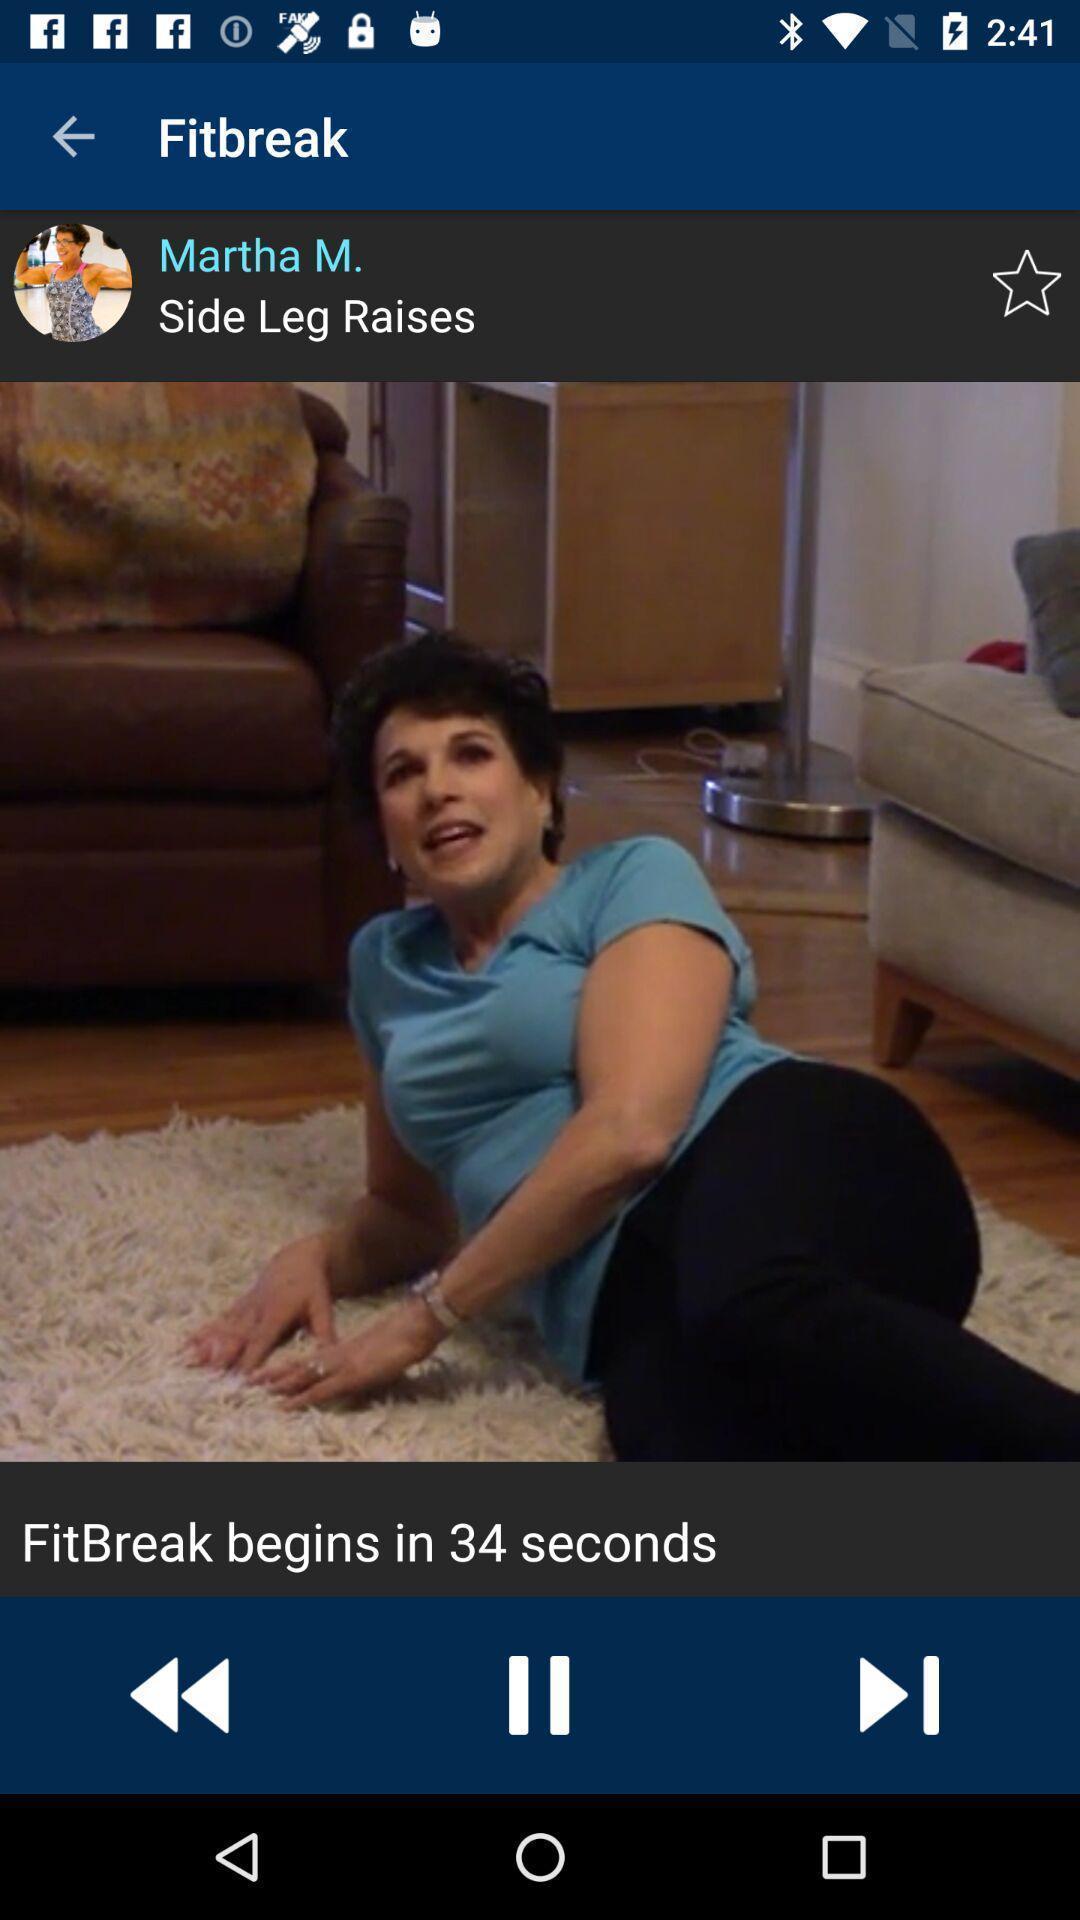Summarize the main components in this picture. Screen displaying page. 